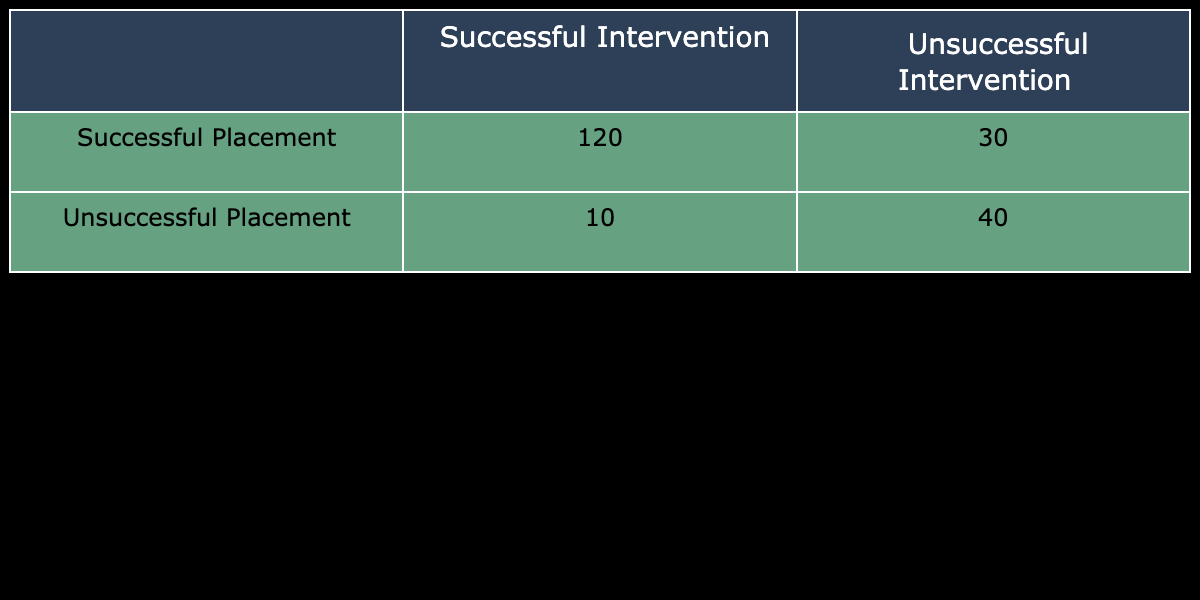What is the total number of placements that were successful? To find the total number of successful placements, we add the values in the "Successful Placement" row. There are 120 successful interventions.
Answer: 120 What is the number of unsuccessful interventions? We can find the number of unsuccessful interventions by looking at the "Unsuccessful Intervention" column and summing up the values. The sum is 30 (from successful placements) + 40 (from unsuccessful placements) = 70.
Answer: 70 What is the total number of unsuccessful placements? The total number of unsuccessful placements is the sum of the two values in the "Unsuccessful Placement" row, which is 10 + 40 = 50.
Answer: 50 Is the number of successful interventions greater than the number of unsuccessful interventions? We can compare the total successful interventions (120) with the total unsuccessful interventions (70). 120 is greater than 70, so the statement is true.
Answer: Yes What percentage of successful placements were successful interventions? To calculate the percentage, we divide the number of successful interventions (120) by the total placements in the "Successful Placement" row (120 + 30 = 150), and then multiply by 100. The calculation is (120/150) * 100 = 80%.
Answer: 80% What is the ratio of successful placements to unsuccessful placements? The ratio can be obtained by comparing the number of successful placements (120) to the number of unsuccessful placements (10). This gives us a ratio of 120:10, which can be simplified to 12:1.
Answer: 12:1 How many more successful interventions are there compared to unsuccessful placements? The number of successful interventions is 120, and the number of unsuccessful placements is 40. The difference is 120 - 40 = 80.
Answer: 80 What is the total number of placements represented in the table? To find the total number of placements, we add up all entries in the table: 120 (successful, successful) + 30 (successful, unsuccessful) + 10 (unsuccessful, successful) + 40 (unsuccessful, unsuccessful). This gives us a total of 300 placements.
Answer: 300 Is the total number of successful interventions less than the total number of placements? The total number of successful interventions is 120, while the total number of placements is 300. Since 120 is less than 300, the statement is true.
Answer: Yes 